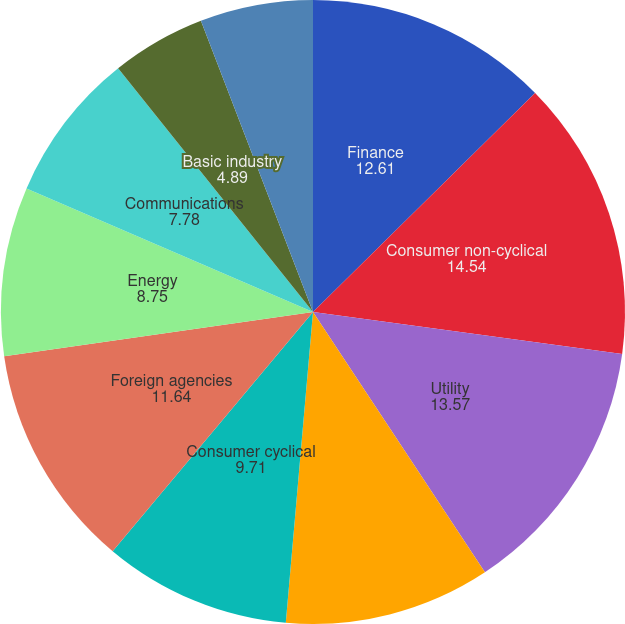Convert chart. <chart><loc_0><loc_0><loc_500><loc_500><pie_chart><fcel>Finance<fcel>Consumer non-cyclical<fcel>Utility<fcel>Capital goods<fcel>Consumer cyclical<fcel>Foreign agencies<fcel>Energy<fcel>Communications<fcel>Basic industry<fcel>Transportation<nl><fcel>12.61%<fcel>14.54%<fcel>13.57%<fcel>10.68%<fcel>9.71%<fcel>11.64%<fcel>8.75%<fcel>7.78%<fcel>4.89%<fcel>5.85%<nl></chart> 